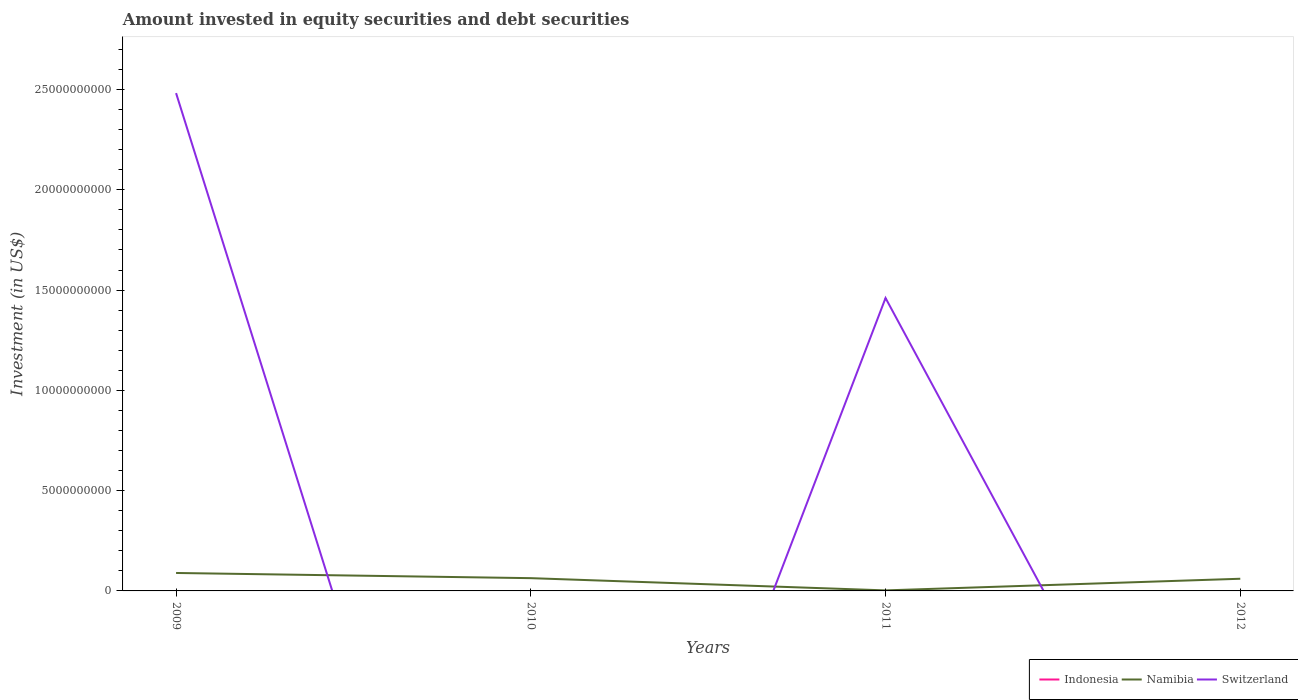How many different coloured lines are there?
Your response must be concise. 2. Does the line corresponding to Indonesia intersect with the line corresponding to Switzerland?
Make the answer very short. Yes. What is the total amount invested in equity securities and debt securities in Namibia in the graph?
Offer a terse response. 2.94e+07. What is the difference between the highest and the second highest amount invested in equity securities and debt securities in Namibia?
Your answer should be compact. 8.69e+08. What is the difference between the highest and the lowest amount invested in equity securities and debt securities in Switzerland?
Ensure brevity in your answer.  2. Is the amount invested in equity securities and debt securities in Switzerland strictly greater than the amount invested in equity securities and debt securities in Namibia over the years?
Ensure brevity in your answer.  No. Does the graph contain any zero values?
Offer a terse response. Yes. Where does the legend appear in the graph?
Provide a succinct answer. Bottom right. How many legend labels are there?
Provide a succinct answer. 3. How are the legend labels stacked?
Your response must be concise. Horizontal. What is the title of the graph?
Give a very brief answer. Amount invested in equity securities and debt securities. What is the label or title of the X-axis?
Offer a terse response. Years. What is the label or title of the Y-axis?
Offer a terse response. Investment (in US$). What is the Investment (in US$) of Indonesia in 2009?
Your response must be concise. 0. What is the Investment (in US$) of Namibia in 2009?
Provide a succinct answer. 8.95e+08. What is the Investment (in US$) of Switzerland in 2009?
Offer a terse response. 2.48e+1. What is the Investment (in US$) of Indonesia in 2010?
Ensure brevity in your answer.  0. What is the Investment (in US$) in Namibia in 2010?
Give a very brief answer. 6.36e+08. What is the Investment (in US$) in Namibia in 2011?
Your response must be concise. 2.65e+07. What is the Investment (in US$) of Switzerland in 2011?
Give a very brief answer. 1.46e+1. What is the Investment (in US$) of Namibia in 2012?
Keep it short and to the point. 6.07e+08. Across all years, what is the maximum Investment (in US$) in Namibia?
Your answer should be very brief. 8.95e+08. Across all years, what is the maximum Investment (in US$) of Switzerland?
Provide a short and direct response. 2.48e+1. Across all years, what is the minimum Investment (in US$) of Namibia?
Provide a succinct answer. 2.65e+07. Across all years, what is the minimum Investment (in US$) in Switzerland?
Offer a very short reply. 0. What is the total Investment (in US$) in Namibia in the graph?
Keep it short and to the point. 2.16e+09. What is the total Investment (in US$) of Switzerland in the graph?
Ensure brevity in your answer.  3.94e+1. What is the difference between the Investment (in US$) of Namibia in 2009 and that in 2010?
Provide a short and direct response. 2.59e+08. What is the difference between the Investment (in US$) of Namibia in 2009 and that in 2011?
Your answer should be very brief. 8.69e+08. What is the difference between the Investment (in US$) in Switzerland in 2009 and that in 2011?
Make the answer very short. 1.02e+1. What is the difference between the Investment (in US$) of Namibia in 2009 and that in 2012?
Keep it short and to the point. 2.88e+08. What is the difference between the Investment (in US$) in Namibia in 2010 and that in 2011?
Provide a short and direct response. 6.10e+08. What is the difference between the Investment (in US$) of Namibia in 2010 and that in 2012?
Provide a short and direct response. 2.94e+07. What is the difference between the Investment (in US$) of Namibia in 2011 and that in 2012?
Provide a short and direct response. -5.80e+08. What is the difference between the Investment (in US$) of Namibia in 2009 and the Investment (in US$) of Switzerland in 2011?
Your response must be concise. -1.37e+1. What is the difference between the Investment (in US$) in Namibia in 2010 and the Investment (in US$) in Switzerland in 2011?
Give a very brief answer. -1.40e+1. What is the average Investment (in US$) in Indonesia per year?
Provide a short and direct response. 0. What is the average Investment (in US$) in Namibia per year?
Offer a terse response. 5.41e+08. What is the average Investment (in US$) of Switzerland per year?
Your answer should be very brief. 9.86e+09. In the year 2009, what is the difference between the Investment (in US$) of Namibia and Investment (in US$) of Switzerland?
Give a very brief answer. -2.39e+1. In the year 2011, what is the difference between the Investment (in US$) of Namibia and Investment (in US$) of Switzerland?
Provide a short and direct response. -1.46e+1. What is the ratio of the Investment (in US$) of Namibia in 2009 to that in 2010?
Give a very brief answer. 1.41. What is the ratio of the Investment (in US$) in Namibia in 2009 to that in 2011?
Offer a very short reply. 33.83. What is the ratio of the Investment (in US$) in Switzerland in 2009 to that in 2011?
Your answer should be compact. 1.7. What is the ratio of the Investment (in US$) of Namibia in 2009 to that in 2012?
Provide a succinct answer. 1.48. What is the ratio of the Investment (in US$) of Namibia in 2010 to that in 2011?
Keep it short and to the point. 24.05. What is the ratio of the Investment (in US$) of Namibia in 2010 to that in 2012?
Provide a succinct answer. 1.05. What is the ratio of the Investment (in US$) of Namibia in 2011 to that in 2012?
Your response must be concise. 0.04. What is the difference between the highest and the second highest Investment (in US$) of Namibia?
Give a very brief answer. 2.59e+08. What is the difference between the highest and the lowest Investment (in US$) of Namibia?
Give a very brief answer. 8.69e+08. What is the difference between the highest and the lowest Investment (in US$) in Switzerland?
Give a very brief answer. 2.48e+1. 